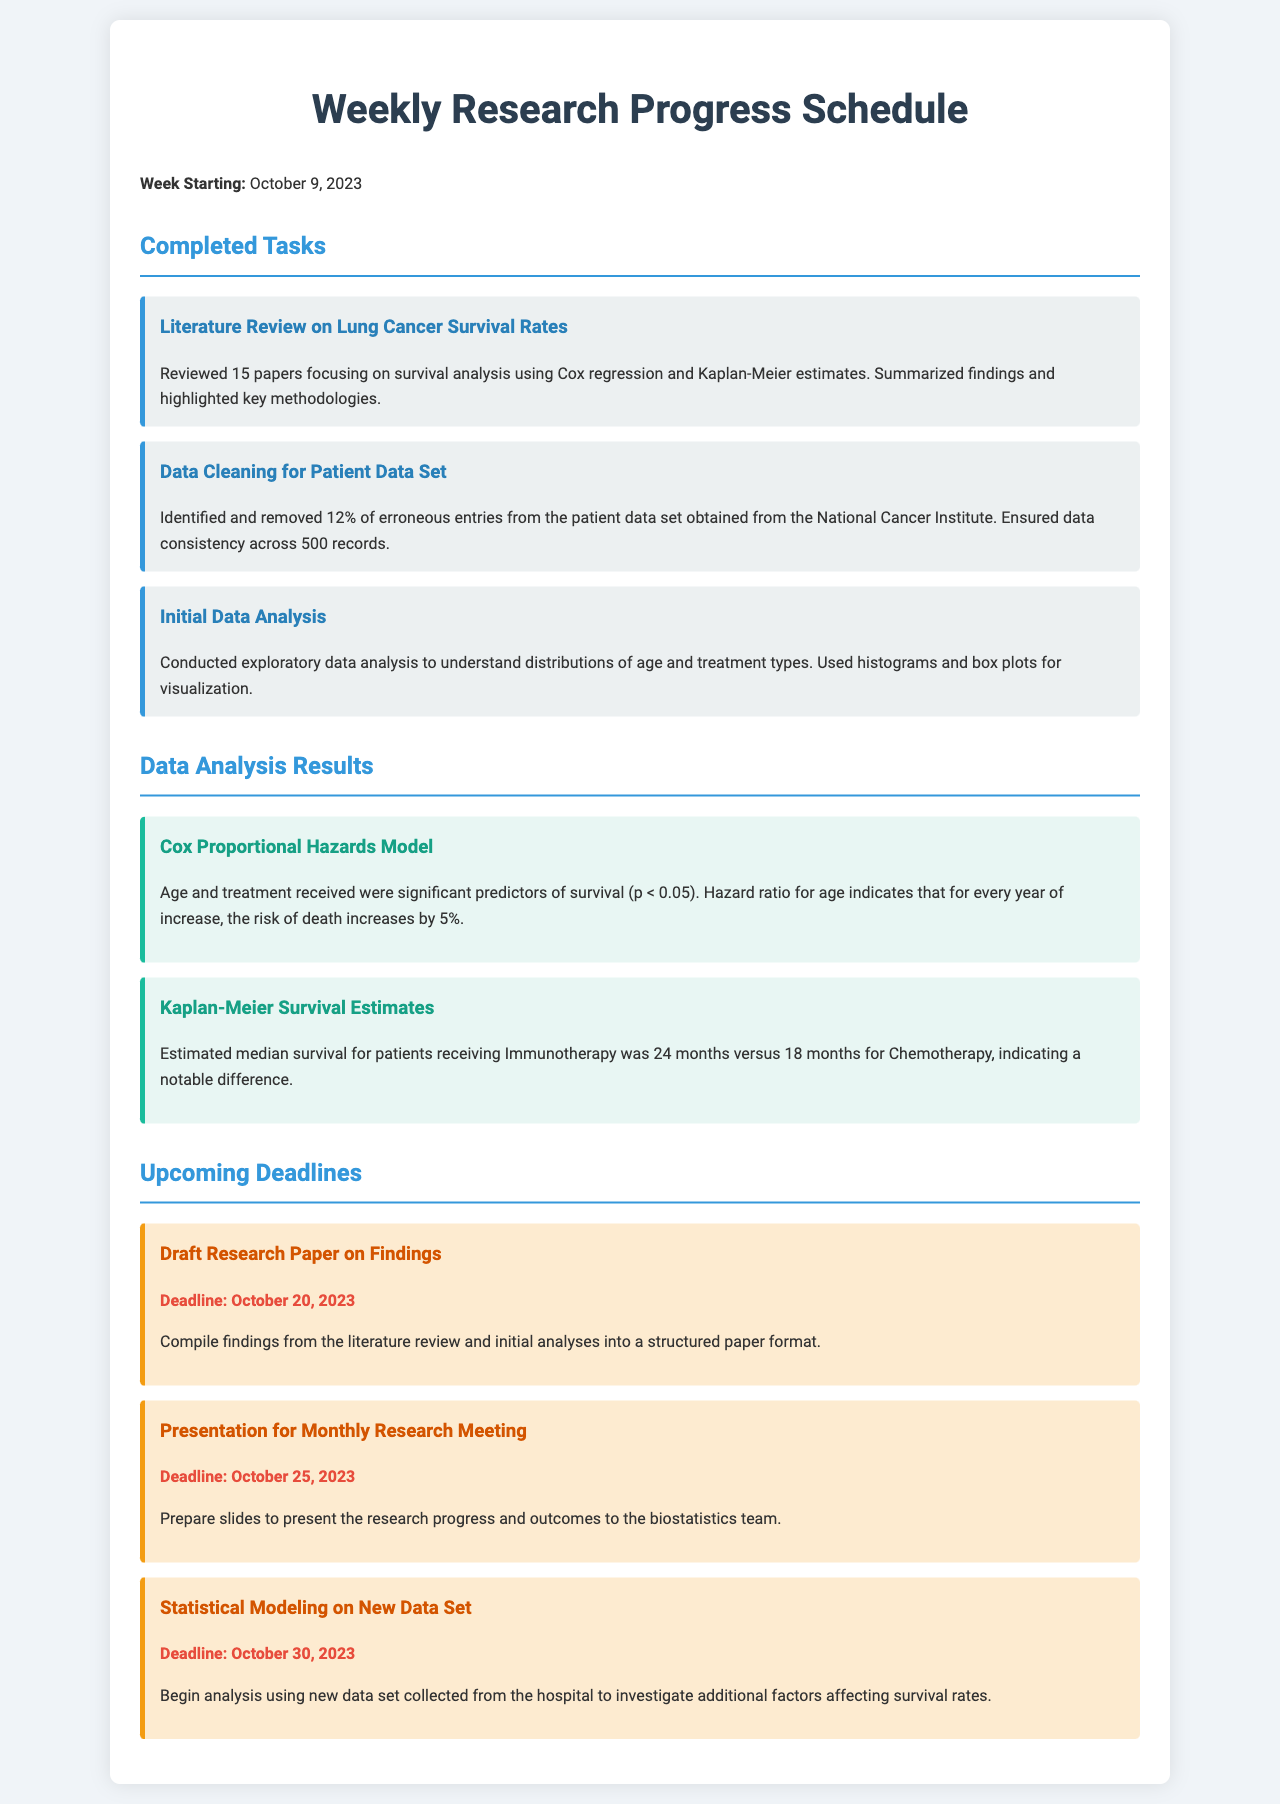What was the week starting date of the schedule? The week starting date is prominently stated at the beginning of the document.
Answer: October 9, 2023 How many papers were reviewed in the literature review? The number of papers reviewed is mentioned in the completed tasks section.
Answer: 15 papers What percentage of erroneous entries was removed from the patient data set? The percentage figure is explicitly stated in the description of the data cleaning task.
Answer: 12% What is the median survival time for patients receiving Immunotherapy? This information is provided in the analysis results related to the Kaplan-Meier survival estimates.
Answer: 24 months What significant predictor of survival was indicated with a p-value less than 0.05? This predictor is identified in the results about the Cox Proportional Hazards Model.
Answer: Age When is the deadline for the draft research paper? The deadline for the draft paper is specifically noted in the upcoming deadlines section.
Answer: October 20, 2023 What type of analysis will begin with the new data set? This is highlighted in the upcoming deadlines under the task for statistical modeling.
Answer: Statistical Modeling Which treatment type had a median survival of 18 months? The treatment type is mentioned alongside the median survival statistics in the analysis results.
Answer: Chemotherapy What is the title of the presentation to be prepared for the monthly research meeting? The title is a distinct task in the upcoming deadlines section.
Answer: Presentation for Monthly Research Meeting 